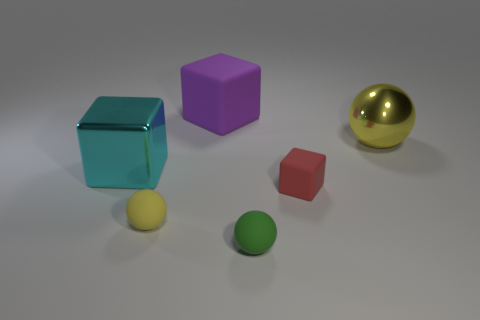If the yellow ball is considered to be a source of light, how does it affect the scene? If the yellow ball is a source of light, we would expect it to cast a glow on the nearby surfaces, creating sharp highlights on objects closest to it, especially on reflective surfaces like the golden ball. It would also create distinct shadows behind the objects opposite to it, which could enhance the scene's three-dimensional feel. 